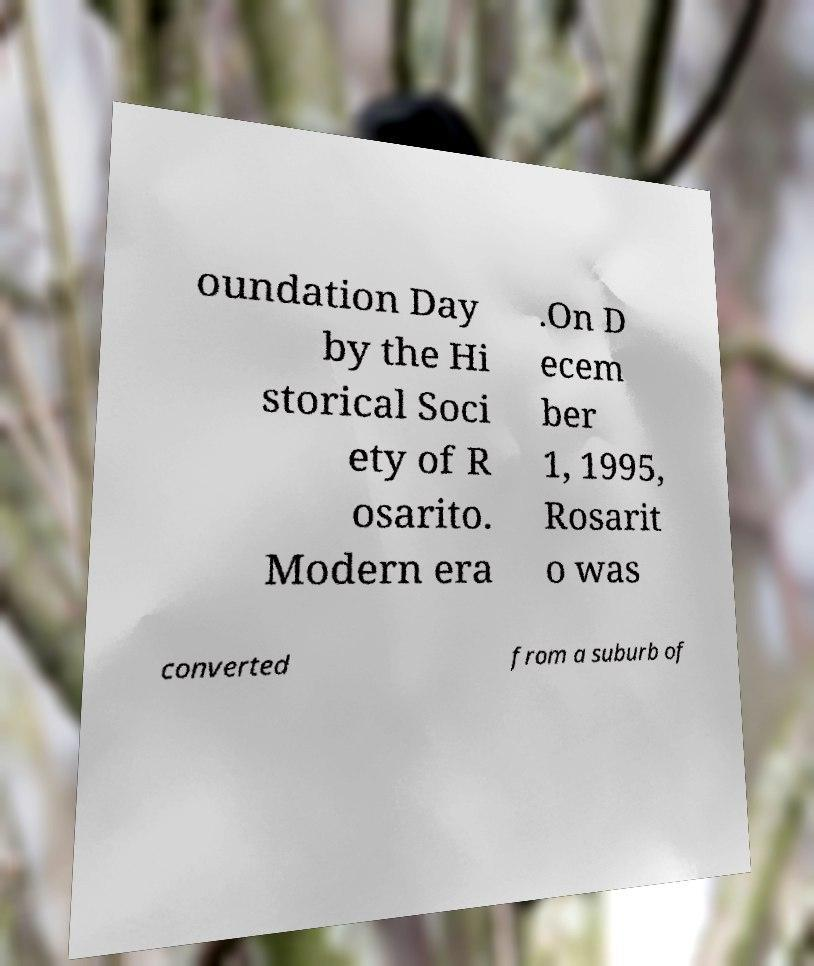For documentation purposes, I need the text within this image transcribed. Could you provide that? oundation Day by the Hi storical Soci ety of R osarito. Modern era .On D ecem ber 1, 1995, Rosarit o was converted from a suburb of 